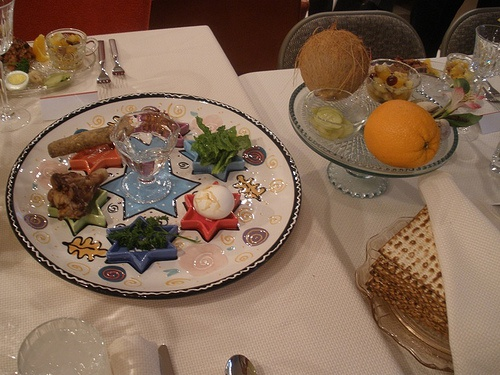Describe the objects in this image and their specific colors. I can see dining table in maroon, tan, and gray tones, cake in maroon, tan, and gray tones, bowl in maroon, gray, and black tones, cup in maroon, gray, and tan tones, and chair in maroon, black, and gray tones in this image. 